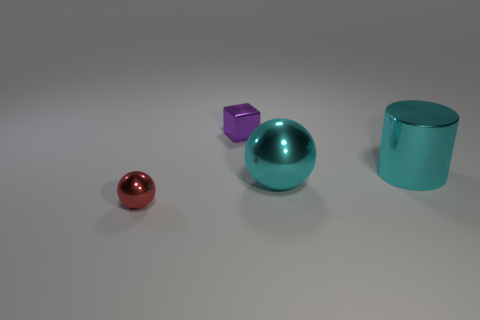What might be the function of these objects if they were real? If these objects were real, they could serve a variety of purposes. The small red sphere might be a decorative object or a paperweight. The purple cube could be a children’s toy or a geometric teaching aid. The large cyan ball seems like it could be part of a modern art installation or a large, inflatable play ball. The teal cylinder might be a container, a sculpture, or possibly a piece of furniture like a stool. 